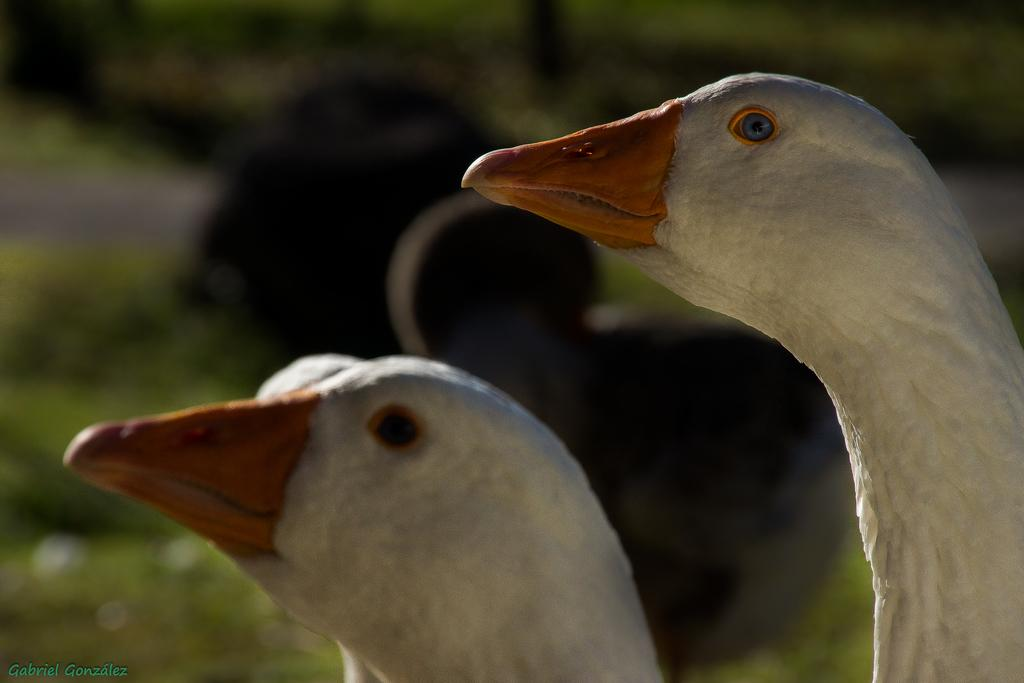How many ducks are present in the image? There are two ducks in the image. What color are the ducks? The ducks are white in color. Can you describe the background of the image? The background of the image is blurred. What is the most prominent feature visible in the image? There is an orange-colored peak visible in the image. What caused the memory loss in the image? There is no indication of memory loss or any related cause in the image. 